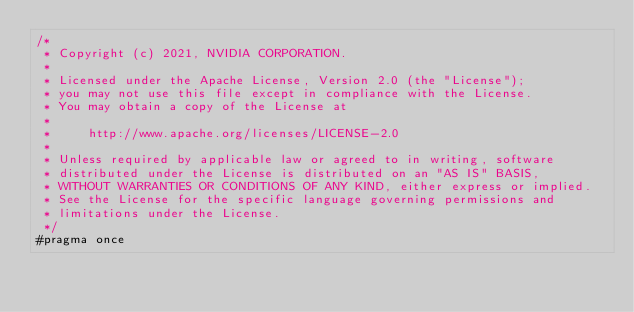Convert code to text. <code><loc_0><loc_0><loc_500><loc_500><_Cuda_>/*
 * Copyright (c) 2021, NVIDIA CORPORATION.
 *
 * Licensed under the Apache License, Version 2.0 (the "License");
 * you may not use this file except in compliance with the License.
 * You may obtain a copy of the License at
 *
 *     http://www.apache.org/licenses/LICENSE-2.0
 *
 * Unless required by applicable law or agreed to in writing, software
 * distributed under the License is distributed on an "AS IS" BASIS,
 * WITHOUT WARRANTIES OR CONDITIONS OF ANY KIND, either express or implied.
 * See the License for the specific language governing permissions and
 * limitations under the License.
 */
#pragma once
</code> 